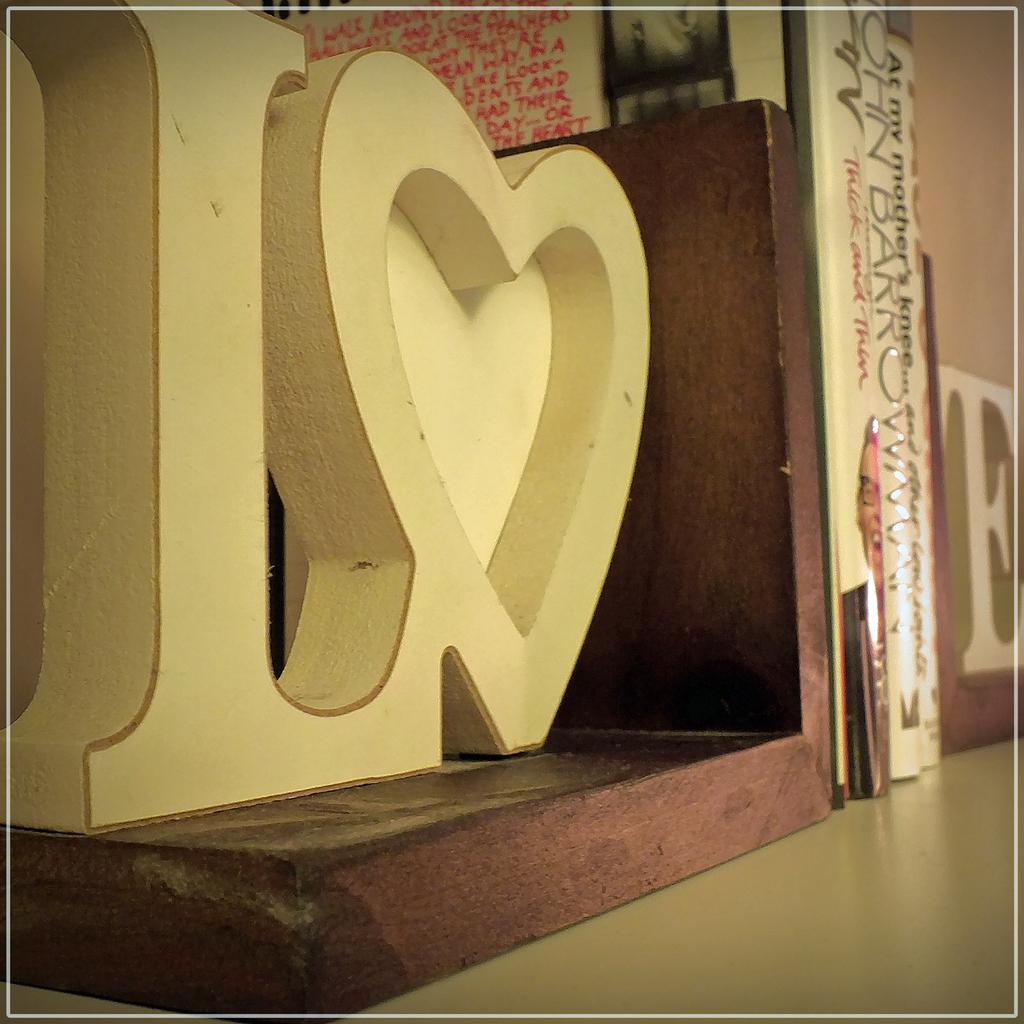<image>
Give a short and clear explanation of the subsequent image. A large white sculpture  showing the letter L 